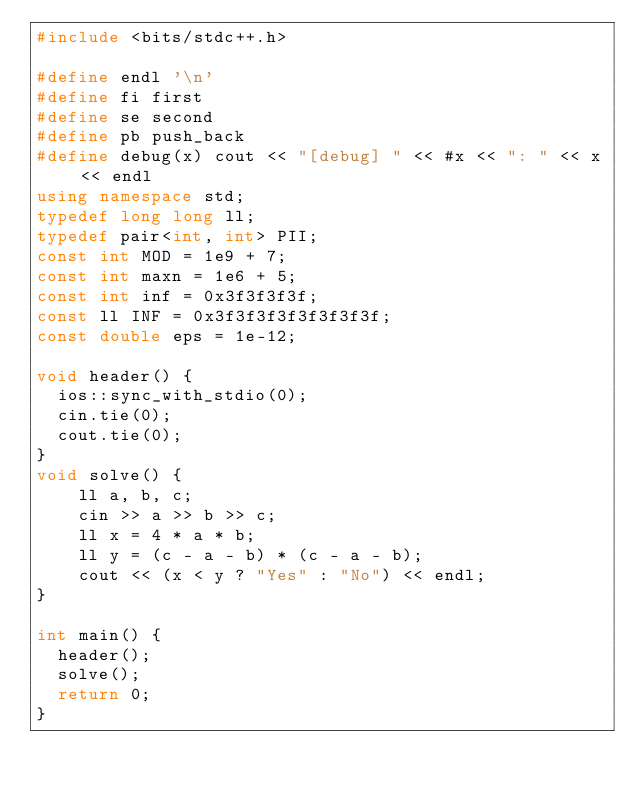<code> <loc_0><loc_0><loc_500><loc_500><_C++_>#include <bits/stdc++.h>

#define endl '\n'
#define fi first
#define se second
#define pb push_back
#define debug(x) cout << "[debug] " << #x << ": " << x << endl
using namespace std;
typedef long long ll;
typedef pair<int, int> PII;
const int MOD = 1e9 + 7;
const int maxn = 1e6 + 5;
const int inf = 0x3f3f3f3f;
const ll INF = 0x3f3f3f3f3f3f3f3f;
const double eps = 1e-12;

void header() {
	ios::sync_with_stdio(0);
	cin.tie(0);
	cout.tie(0);
}
void solve() {
    ll a, b, c;
    cin >> a >> b >> c;
    ll x = 4 * a * b;
    ll y = (c - a - b) * (c - a - b);
    cout << (x < y ? "Yes" : "No") << endl;
}

int main() {
	header();
	solve();
	return 0;
}
</code> 